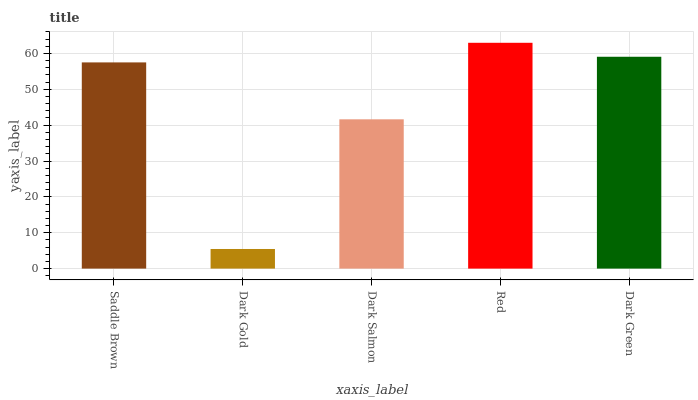Is Dark Gold the minimum?
Answer yes or no. Yes. Is Red the maximum?
Answer yes or no. Yes. Is Dark Salmon the minimum?
Answer yes or no. No. Is Dark Salmon the maximum?
Answer yes or no. No. Is Dark Salmon greater than Dark Gold?
Answer yes or no. Yes. Is Dark Gold less than Dark Salmon?
Answer yes or no. Yes. Is Dark Gold greater than Dark Salmon?
Answer yes or no. No. Is Dark Salmon less than Dark Gold?
Answer yes or no. No. Is Saddle Brown the high median?
Answer yes or no. Yes. Is Saddle Brown the low median?
Answer yes or no. Yes. Is Dark Gold the high median?
Answer yes or no. No. Is Dark Salmon the low median?
Answer yes or no. No. 